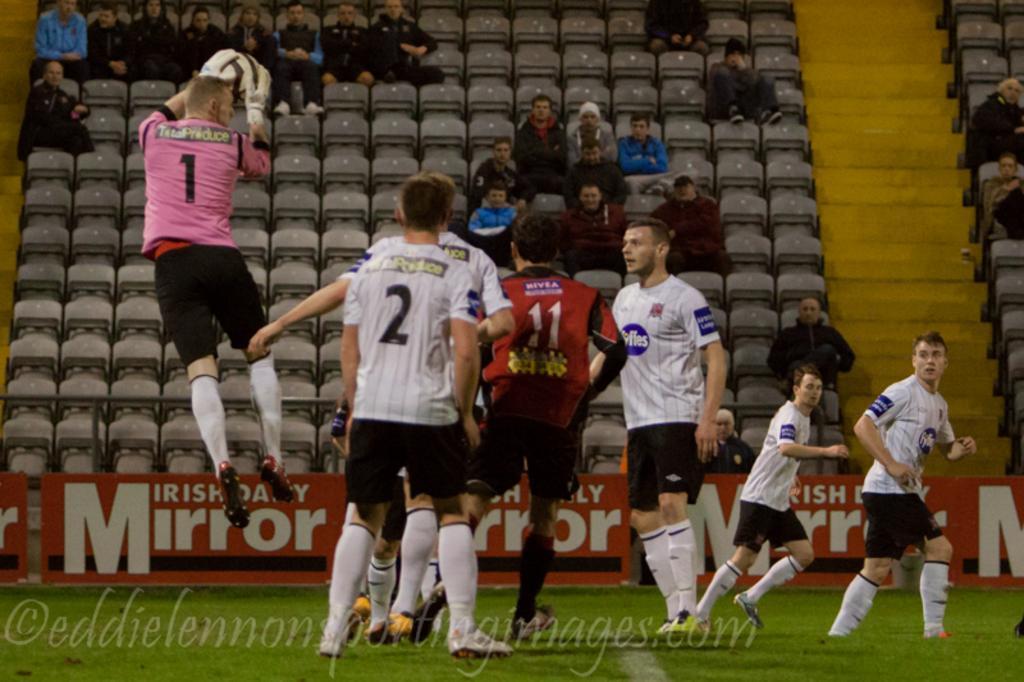How would you summarize this image in a sentence or two? This picture is taken in a football stadium, There are some people playing the football, In the left side there is a man jumping and he is holding a football which is in white color, In the background there are some people sitting on the chairs and watching the match. 